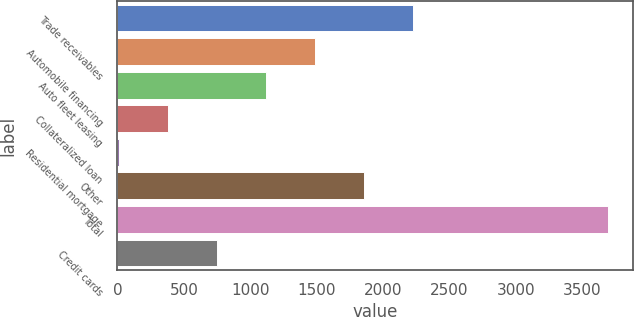Convert chart. <chart><loc_0><loc_0><loc_500><loc_500><bar_chart><fcel>Trade receivables<fcel>Automobile financing<fcel>Auto fleet leasing<fcel>Collateralized loan<fcel>Residential mortgage<fcel>Other<fcel>Total<fcel>Credit cards<nl><fcel>2224<fcel>1487<fcel>1118.5<fcel>381.5<fcel>13<fcel>1855.5<fcel>3698<fcel>750<nl></chart> 